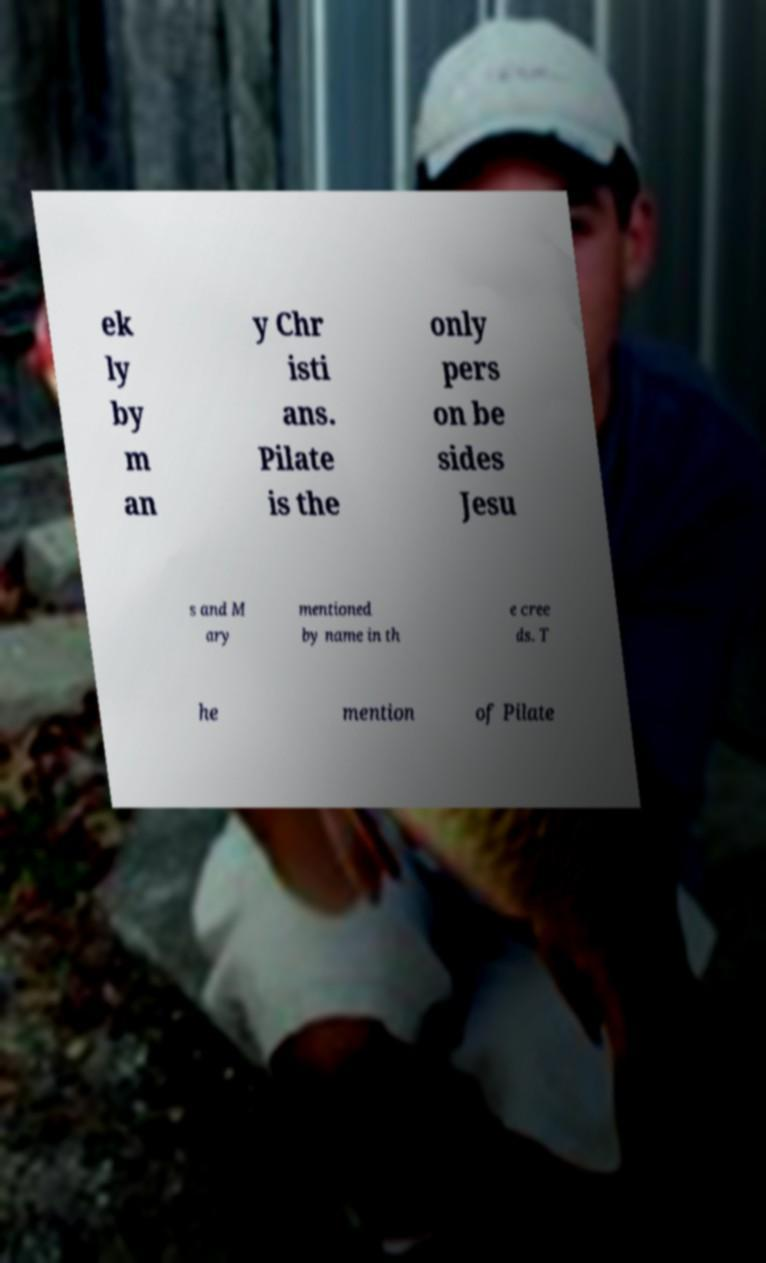I need the written content from this picture converted into text. Can you do that? ek ly by m an y Chr isti ans. Pilate is the only pers on be sides Jesu s and M ary mentioned by name in th e cree ds. T he mention of Pilate 